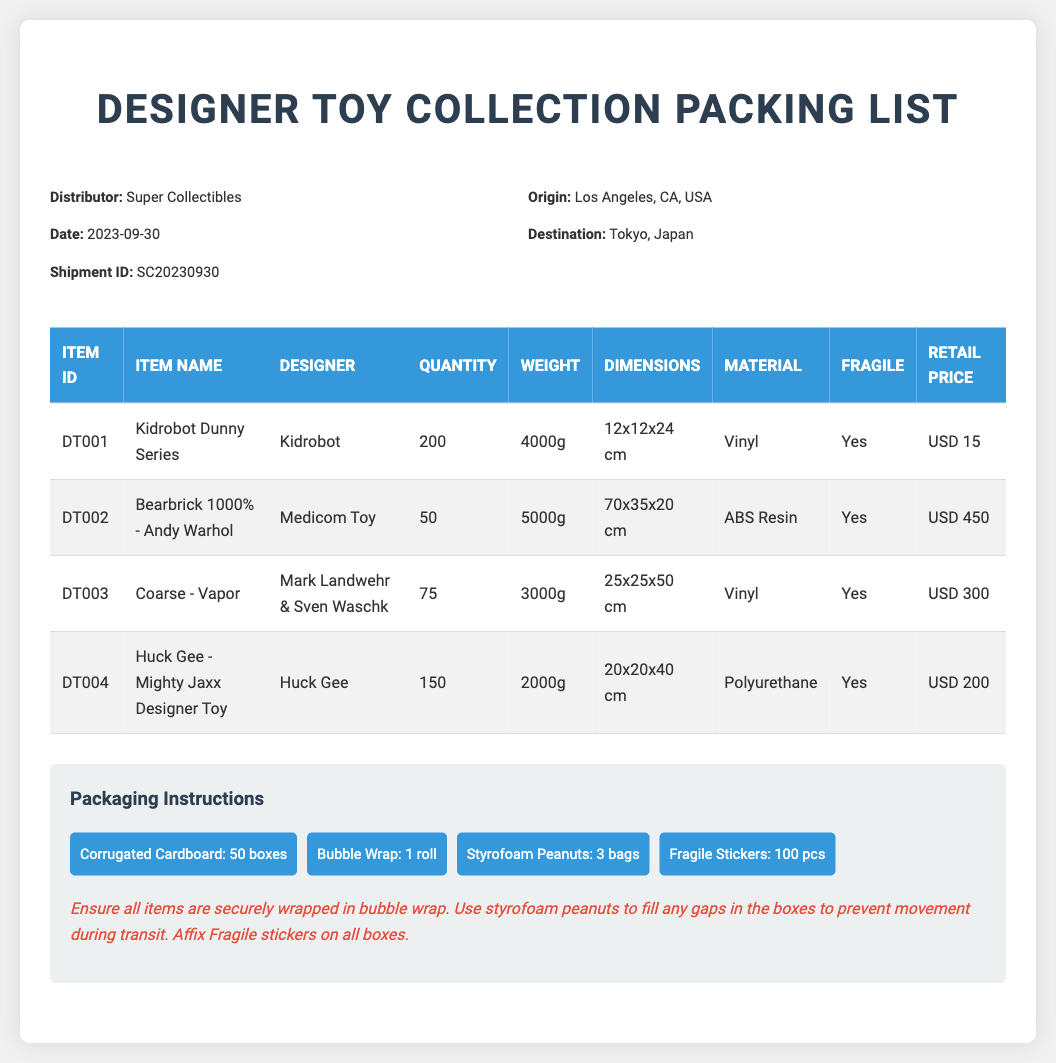What is the shipment ID? The shipment ID is specified in the header section of the document.
Answer: SC20230930 Who is the designer of the Bearbrick 1000% - Andy Warhol? The designer's name for this item is listed in the table of items.
Answer: Medicom Toy What is the total quantity of Kidrobot Dunny Series? The total quantity is found in the quantity column of the item table.
Answer: 200 Which item has the highest retail price? This requires comparing the retail prices listed in the table.
Answer: Bearbrick 1000% - Andy Warhol What material is used for the Coarse - Vapor? The material for this item is in the respective item's details.
Answer: Vinyl How many fragiles stickers are included in the packaging materials? The number of fragile stickers can be found under the packaging instructions.
Answer: 100 pcs What is the weight of Huck Gee - Mighty Jaxx Designer Toy? The weight is specified in the weight column of the item table.
Answer: 2000g Which item is noted as having the largest dimensions? This requires examining the dimensions provided for each item.
Answer: Bearbrick 1000% - Andy Warhol What instructions are given for packaging? These instructions detail how to securely wrap items and prevent movement during transit.
Answer: Ensure all items are securely wrapped in bubble wrap 